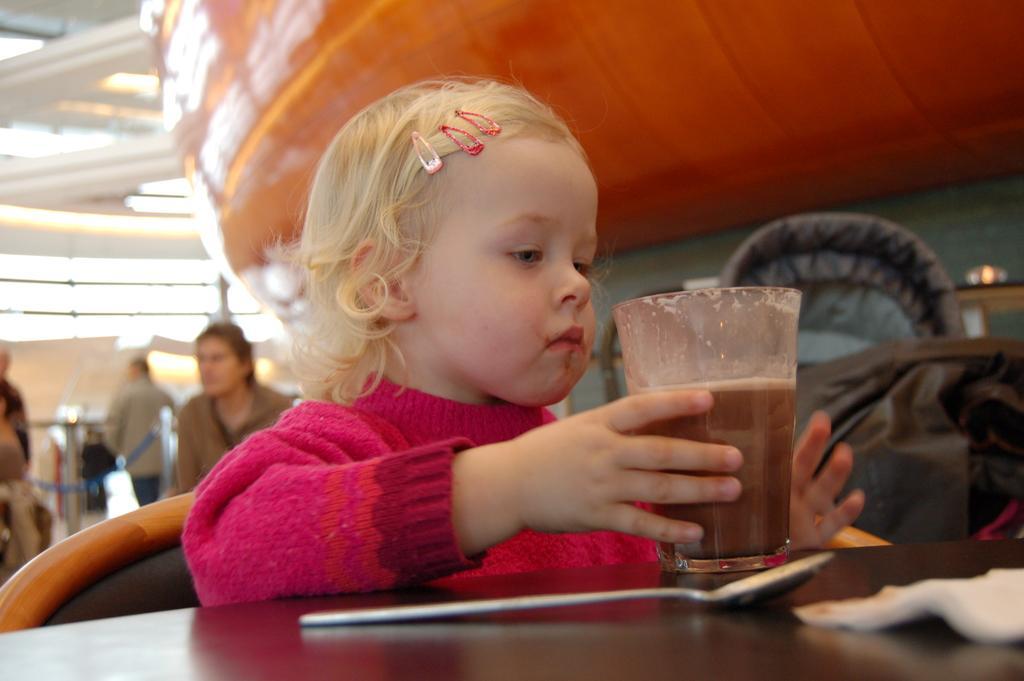Please provide a concise description of this image. In this picture I can observe girl sitting on the chair in front of a table. There is a glass placed on the table. The background is blurred. 